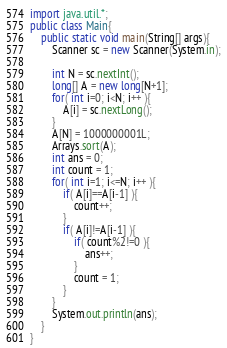<code> <loc_0><loc_0><loc_500><loc_500><_Java_>import java.util.*;
public class Main{
	public static void main(String[] args){
		Scanner sc = new Scanner(System.in);

		int N = sc.nextInt();
		long[] A = new long[N+1];
		for( int i=0; i<N; i++ ){
			A[i] = sc.nextLong();
		}
		A[N] = 1000000001L;
		Arrays.sort(A);
		int ans = 0;
		int count = 1;
		for( int i=1; i<=N; i++ ){
			if( A[i]==A[i-1] ){
				count++;
			}
			if( A[i]!=A[i-1] ){
				if( count%2!=0 ){
					ans++;
				}
				count = 1;
			}
		}
		System.out.println(ans);
	}
}
</code> 